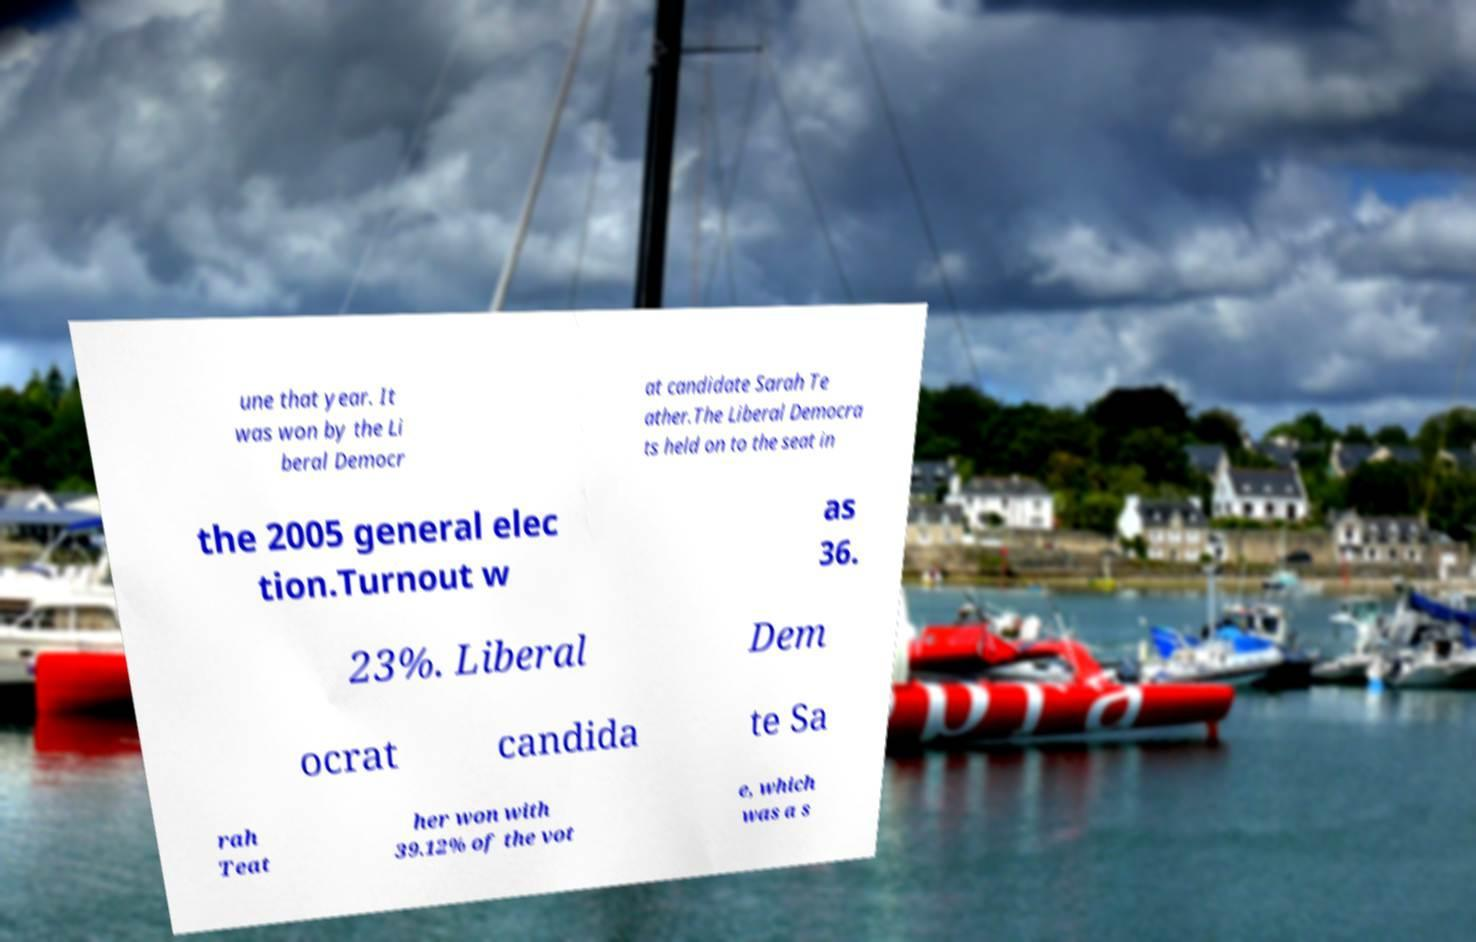Could you assist in decoding the text presented in this image and type it out clearly? une that year. It was won by the Li beral Democr at candidate Sarah Te ather.The Liberal Democra ts held on to the seat in the 2005 general elec tion.Turnout w as 36. 23%. Liberal Dem ocrat candida te Sa rah Teat her won with 39.12% of the vot e, which was a s 